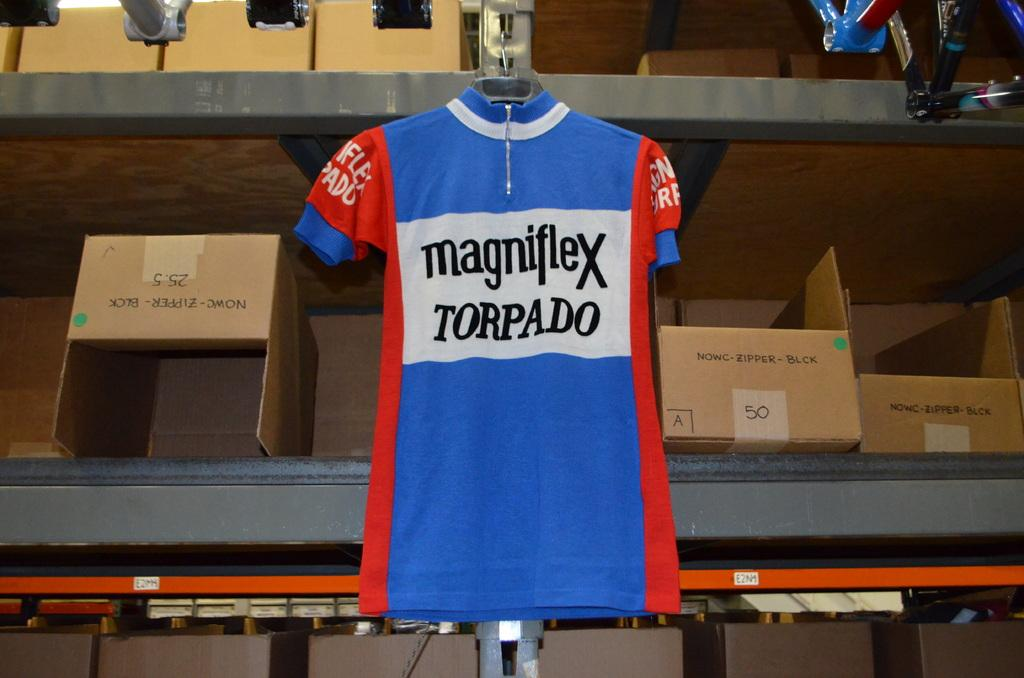<image>
Write a terse but informative summary of the picture. A shirt on a hangar hangs that reads magniflex torpado 